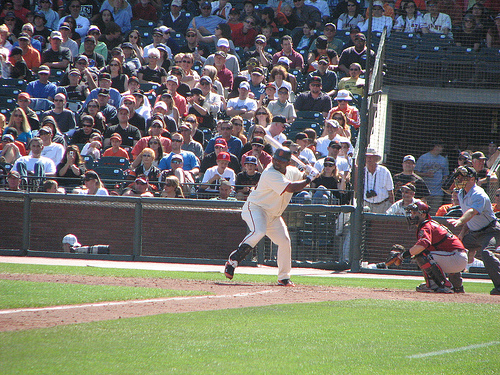What is happening in this moment in the game? The image captures the precise moment when the batter is swinging at the pitch. It's a dynamic instance that epitomizes the anticipation and skill involved in baseball. Can you tell me more about the team uniforms? The batter is clad in a white uniform, typical for home teams in baseball, while the catcher and the visible umpire wear darker gear, possibly indicating away colors for the umpire's uniform. 